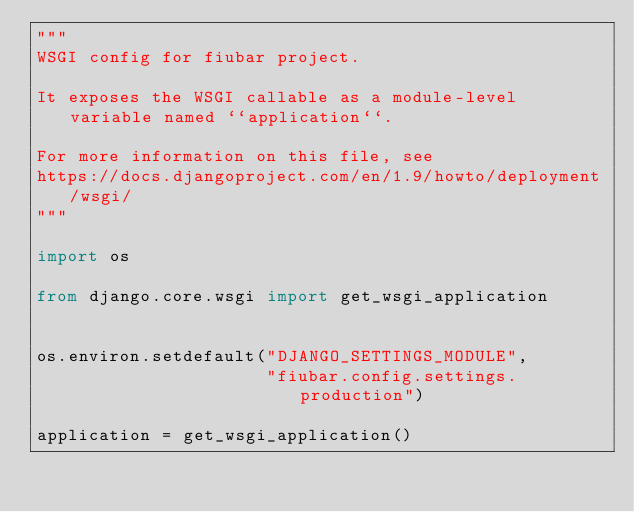<code> <loc_0><loc_0><loc_500><loc_500><_Python_>"""
WSGI config for fiubar project.

It exposes the WSGI callable as a module-level variable named ``application``.

For more information on this file, see
https://docs.djangoproject.com/en/1.9/howto/deployment/wsgi/
"""

import os

from django.core.wsgi import get_wsgi_application


os.environ.setdefault("DJANGO_SETTINGS_MODULE",
                      "fiubar.config.settings.production")

application = get_wsgi_application()
</code> 